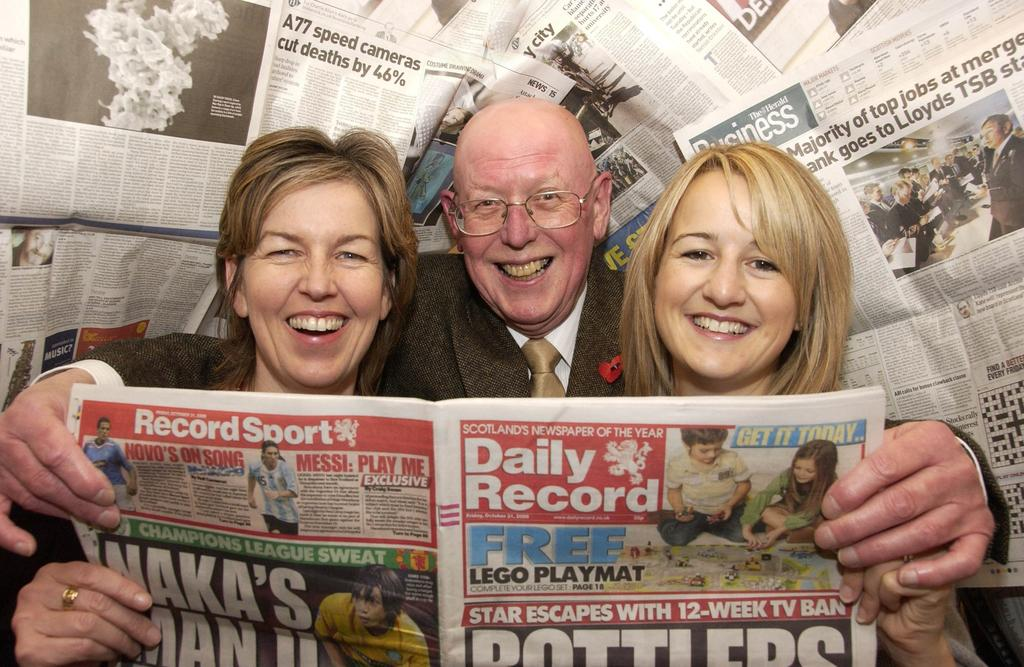How many people are present in the image? There are three people in the image: one man and two women. What are the people holding in the image? The man and women are holding a newspaper. Can you describe the content of the newspaper? The newspaper contains pictures and text. Are there any additional newspapers visible in the image? Yes, there are additional newspapers visible on the backside. What type of whip is being used to create waves in the image? There is no whip or waves present in the image; it features a man and two women holding a newspaper. Can you describe the color of the rat in the image? There is no rat present in the image. 